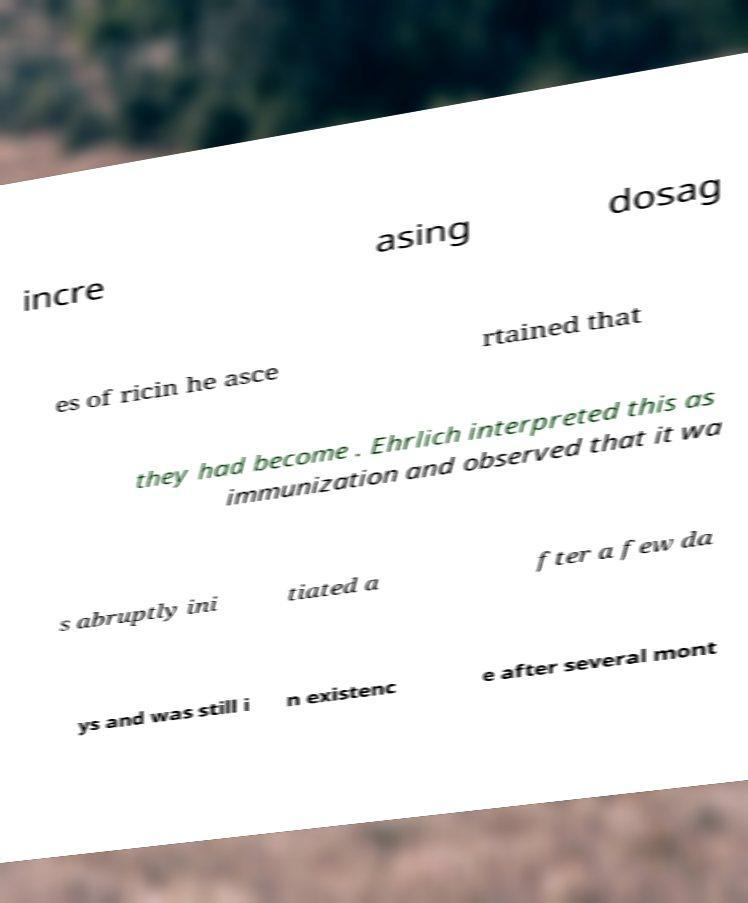For documentation purposes, I need the text within this image transcribed. Could you provide that? incre asing dosag es of ricin he asce rtained that they had become . Ehrlich interpreted this as immunization and observed that it wa s abruptly ini tiated a fter a few da ys and was still i n existenc e after several mont 